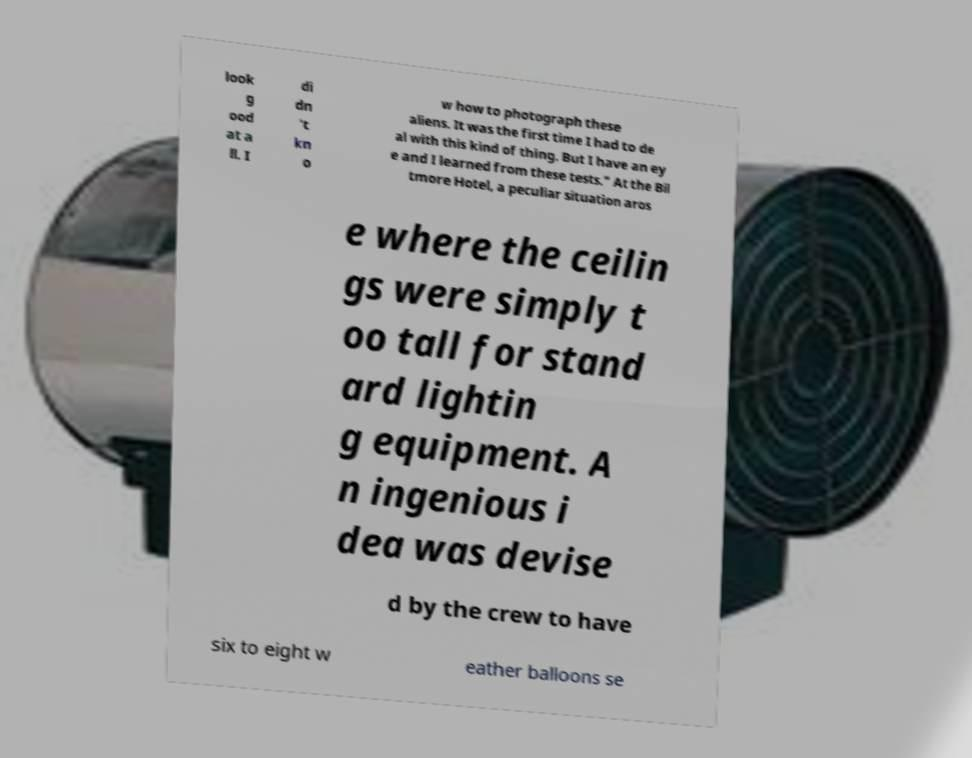Please identify and transcribe the text found in this image. look g ood at a ll. I di dn 't kn o w how to photograph these aliens. It was the first time I had to de al with this kind of thing. But I have an ey e and I learned from these tests." At the Bil tmore Hotel, a peculiar situation aros e where the ceilin gs were simply t oo tall for stand ard lightin g equipment. A n ingenious i dea was devise d by the crew to have six to eight w eather balloons se 